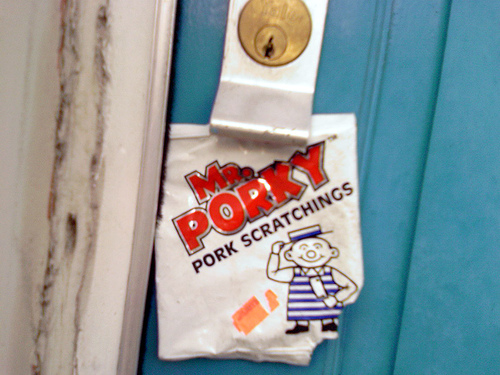<image>
Can you confirm if the door is behind the mr porky? Yes. From this viewpoint, the door is positioned behind the mr porky, with the mr porky partially or fully occluding the door. 